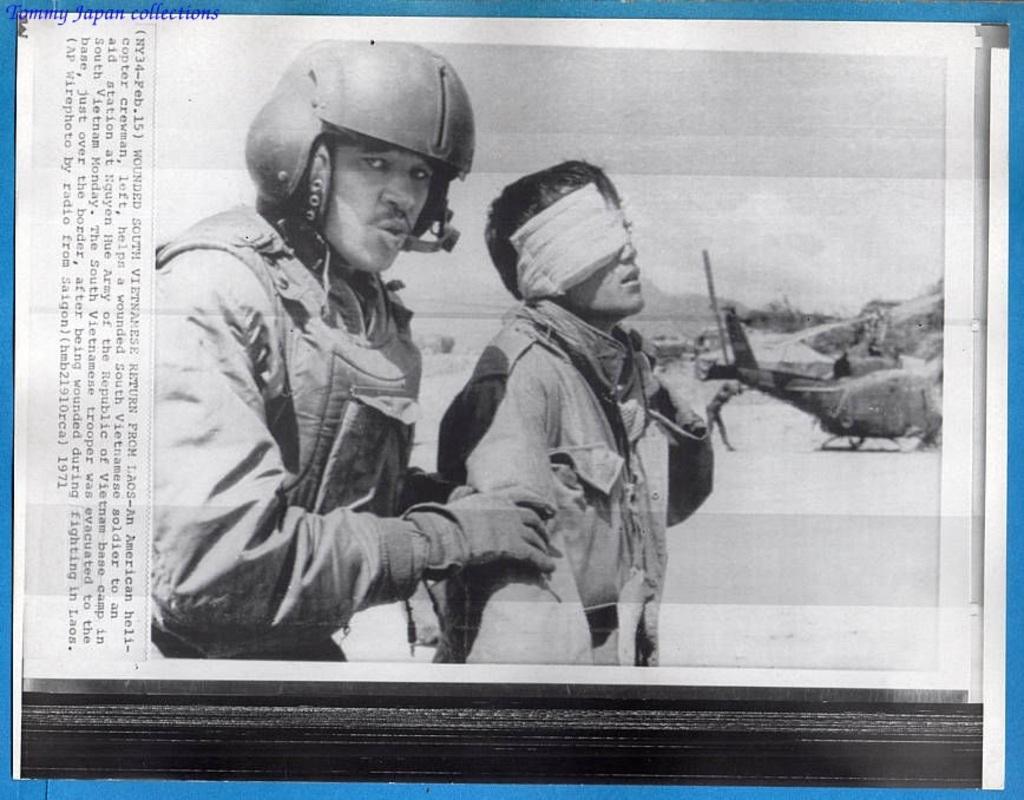Please provide a concise description of this image. In the image we can see black and picture. In it we can see two men wearing clothes and left side man is wearing gloves and a helmet. Here we can see the flying jet and the sky. We can even see the text. 